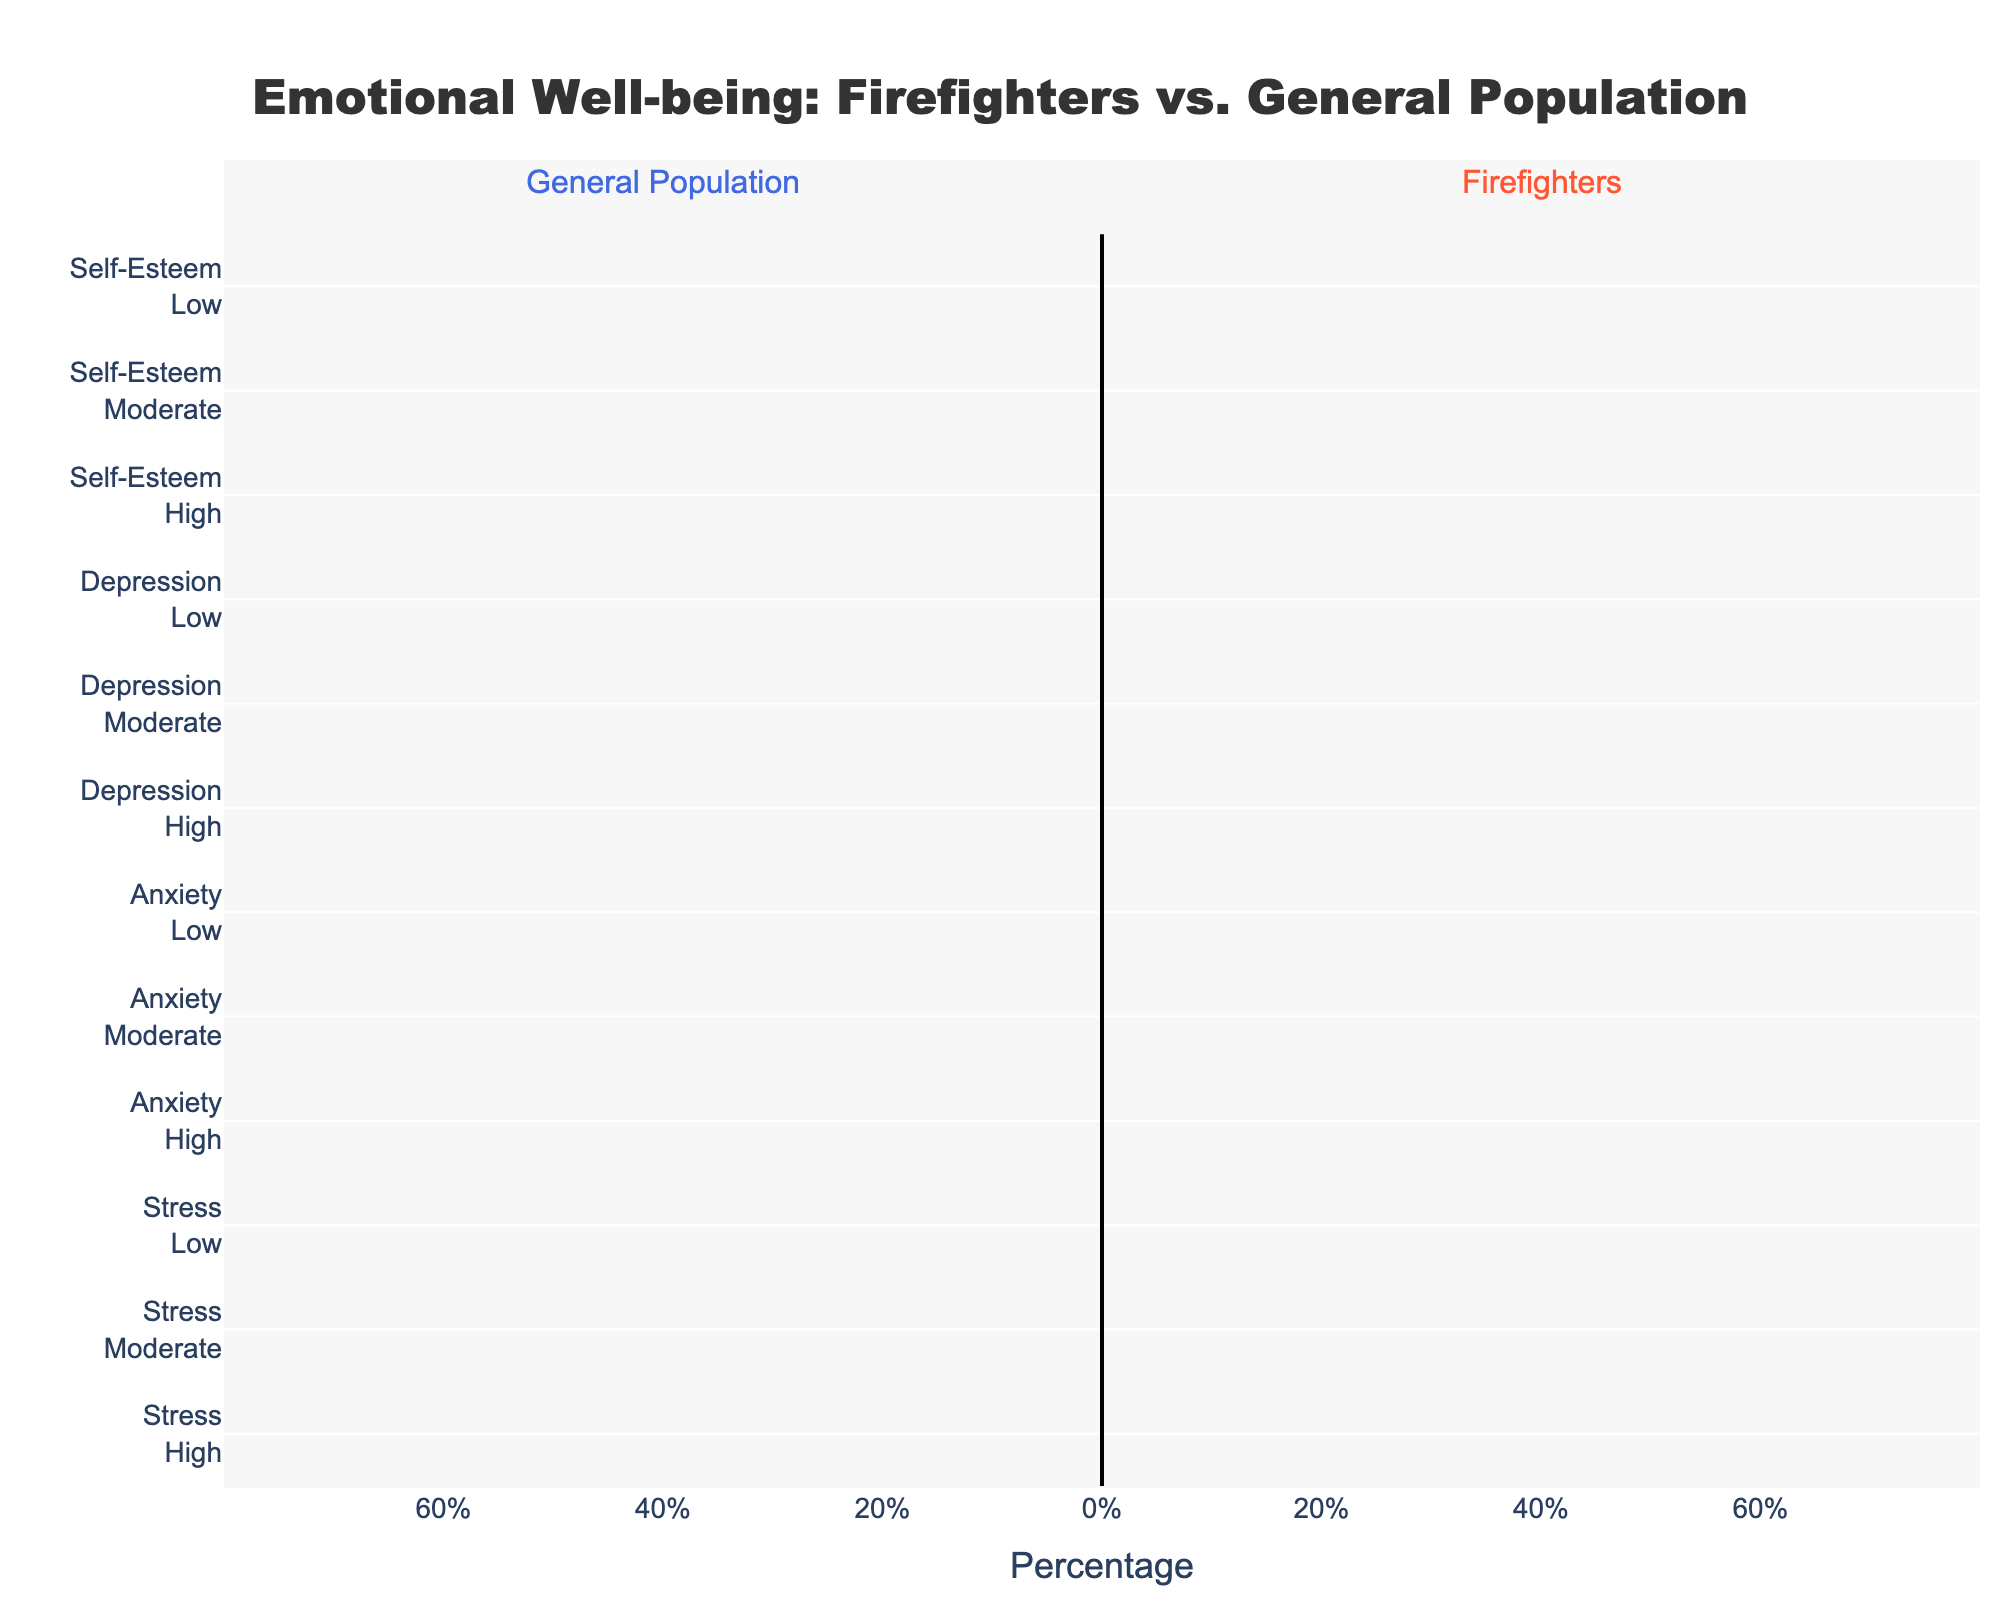what percentage of firefighters reported high levels of self-esteem? Looking at the light orange bar corresponding to "Self-Esteem<br>High" under the Firefighters section, it reads 60%.
Answer: 60% How does the level of high depression compare between firefighters and the general population? Comparing the orange bar for "Depression<br>High" under Firefighters (10%) with the blue bar for "Depression<br>High" under General Population (-5%), firefighters report a higher percentage of high depression.
Answer: Firefighters have 5% more Which group has a higher percentage of low anxiety? The lengths of the corresponding bars indicate that General Population has a low anxiety percentage of 65% while Firefighters have 45%, so the General Population has a higher percentage.
Answer: General Population Compare the difference in moderate stress levels between firefighters and the general population. Firefighters have a moderate stress percentage of 40%, and the General Population has 30%. The difference is 40% - 30% = 10%.
Answer: 10% What is the average percentage of high anxiety reported in both groups? The high anxiety is 20% for firefighters and 10% for the general population. The average is (20% + 10%) / 2 = 15%.
Answer: 15% Which group shows a greater percentage of moderate self-esteem? The Firefighters have a moderate self-esteem percentage of 25% while the General Population has 20%. Firefighters show a higher percentage.
Answer: Firefighters What is the total percentage of low depression in both groups combined? Firefighters report 60% low depression and the General Population reports 75% low depression. Total is 60% + 75% = 135%.
Answer: 135% Which group has a smaller percentage of moderate anxiety? Firefighters have a moderate anxiety percentage of 35% and the general population has 25%. The General Population has the smaller percentage.
Answer: General Population Compare the visual lengths of the bars for high stress between the two groups. The orange bar for high stress under firefighters is longer at 25% compared to the blue bar of the General Population at 15%.
Answer: Firefighters have longer bars What is the difference in the percentage of low self-esteem between firefighters and the general population? Firefighters show 15% low self-esteem, while the General Population shows 10%. The difference is 15% - 10% = 5%.
Answer: 5% 